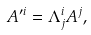Convert formula to latex. <formula><loc_0><loc_0><loc_500><loc_500>A ^ { \prime i } = \Lambda _ { j } ^ { i } A ^ { j } ,</formula> 